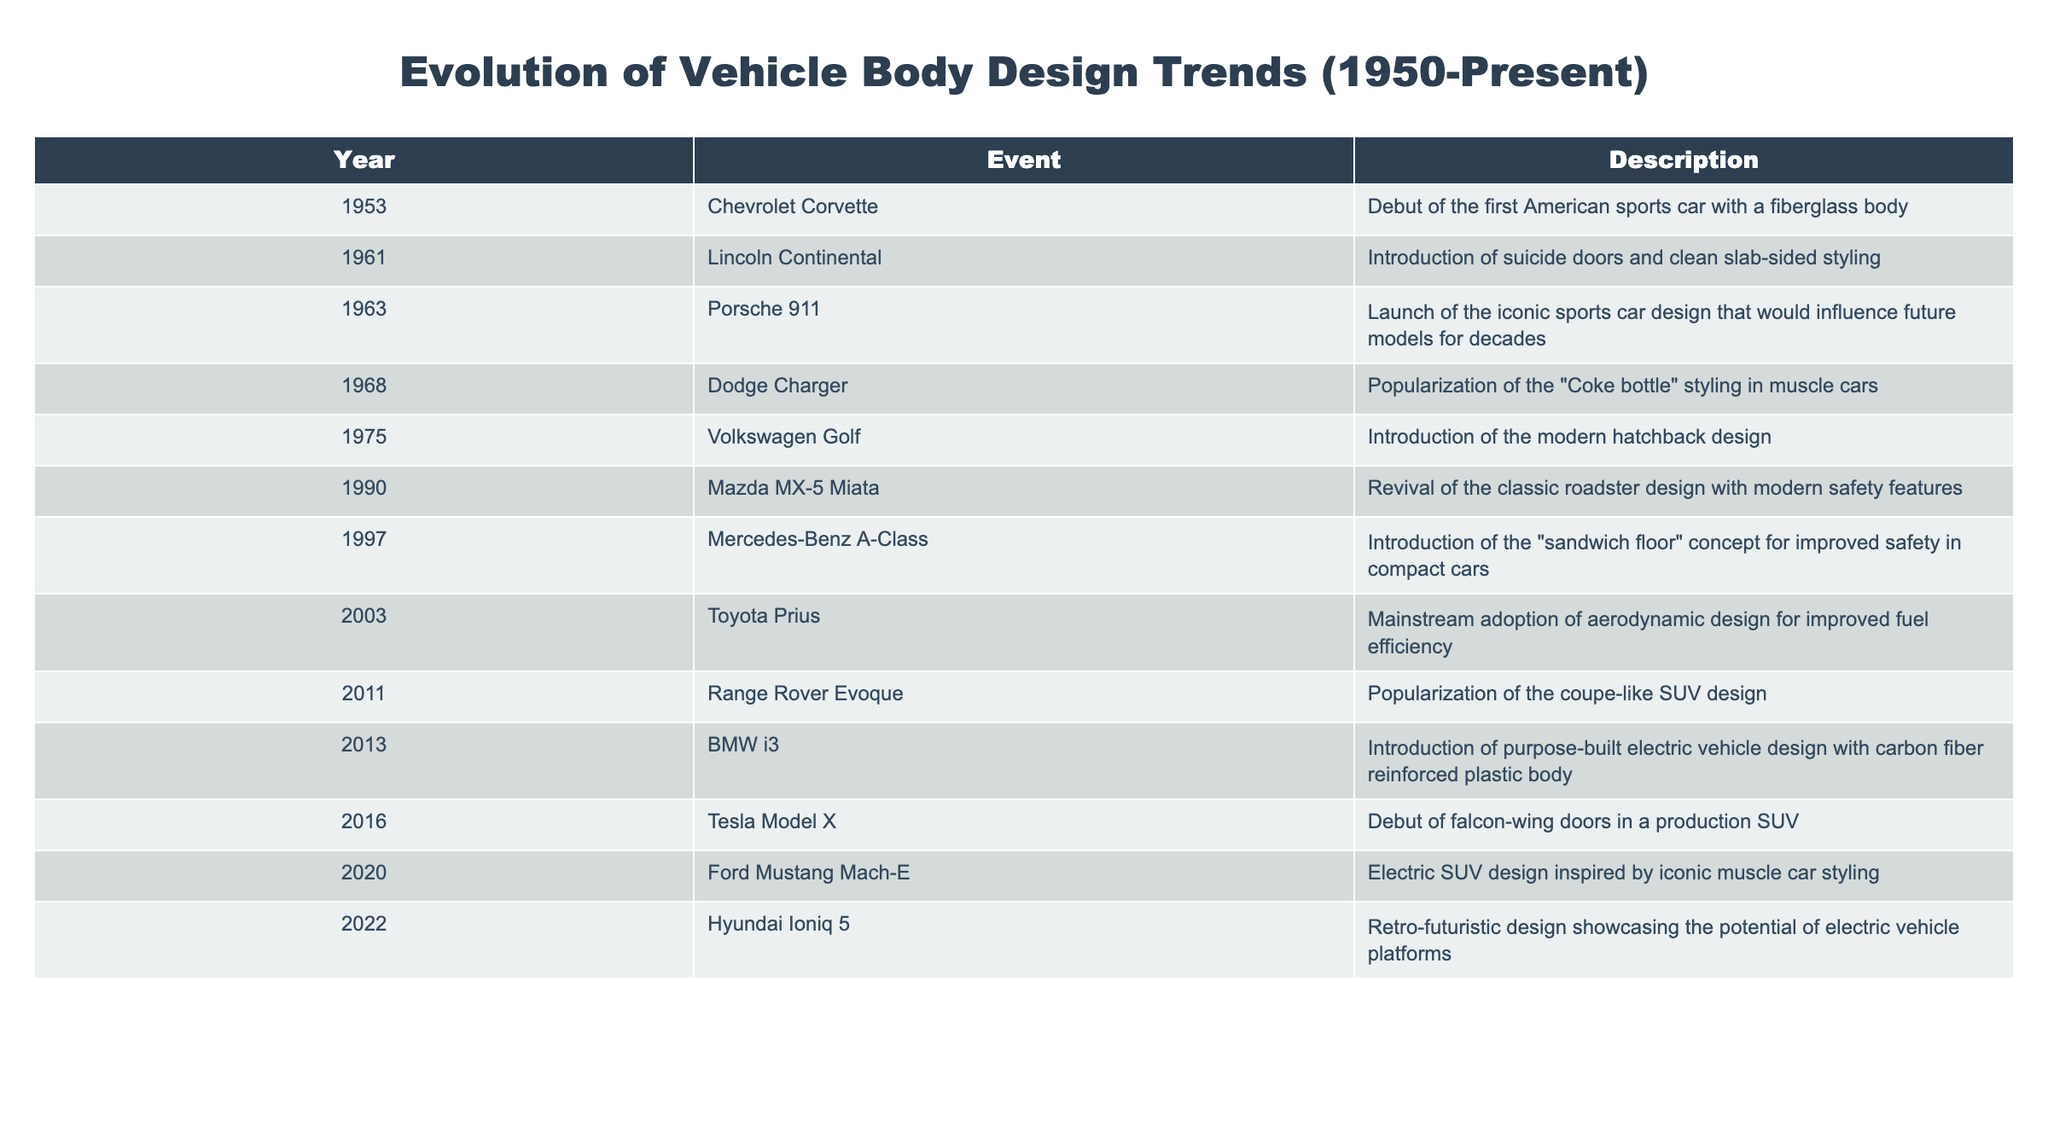What vehicle was the first American sports car with a fiberglass body? According to the table, the 1953 Chevrolet Corvette is noted as the debut of the first American sports car with a fiberglass body.
Answer: Chevrolet Corvette In which year did the iconic Porsche 911 launch? The table clearly indicates that the Porsche 911 was launched in 1963.
Answer: 1963 Which vehicle introduced the "Coke bottle" styling in muscle cars? Referring to the table, it shows that the Dodge Charger popularized the "Coke bottle" styling in 1968.
Answer: Dodge Charger What was the trend introduced by the Mercedes-Benz A-Class in 1997? The description in the table specifies that the Mercedes-Benz A-Class introduced the "sandwich floor" concept for improved safety in compact cars.
Answer: Sandwich floor concept How many events occurred in the 2010s decade according to the table? The table shows three events listed in the 2010s decade: the Range Rover Evoque (2011), the BMW i3 (2013), and the Tesla Model X (2016). Therefore, we count them to find there are three events.
Answer: 3 Did Volkswagen Golf introduce the hatchback design in 1975? According to the table, the Volkswagen Golf was indeed introduced as the modern hatchback design in 1975, thus confirming the statement.
Answer: Yes Which vehicle features falcon-wing doors? The table indicates that the Tesla Model X, launched in 2016, features falcon-wing doors in production SUVs.
Answer: Tesla Model X What is the chronological gap between the introduction of the sports car design of the Porsche 911 and the Mazda MX-5 Miata? By checking the years, you find Porsche 911 in 1963 and Mazda MX-5 Miata in 1990. The difference is 1990 - 1963 = 27 years.
Answer: 27 years Which model was noted for its retro-futuristic design, and in what year was it introduced? The table states that the Hyundai Ioniq 5 is celebrated for its retro-futuristic design and was introduced in 2022.
Answer: Hyundai Ioniq 5, 2022 